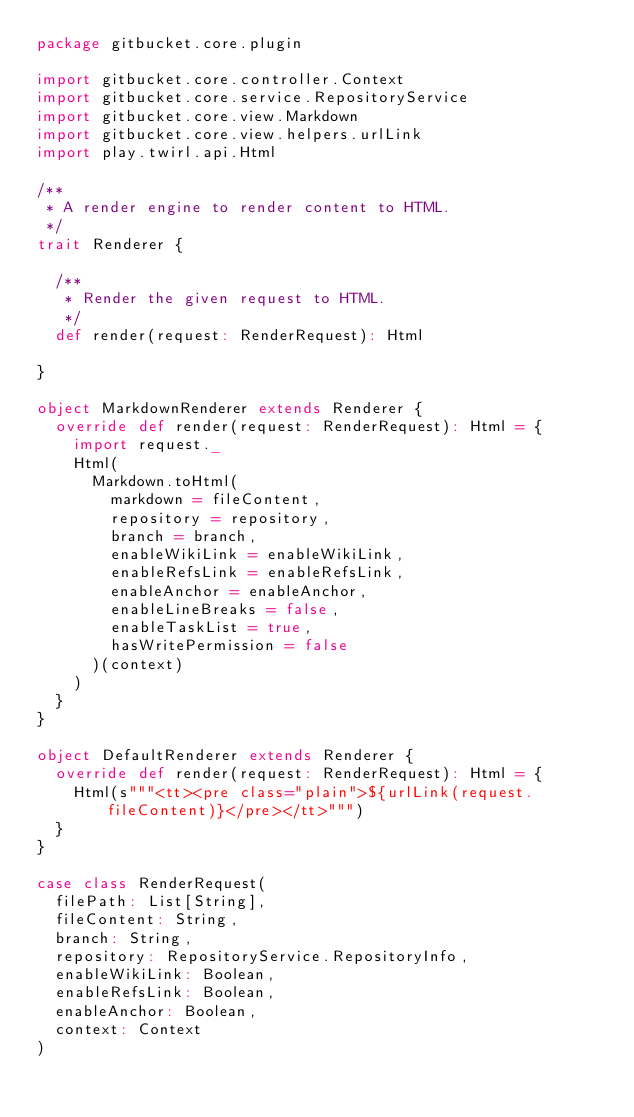<code> <loc_0><loc_0><loc_500><loc_500><_Scala_>package gitbucket.core.plugin

import gitbucket.core.controller.Context
import gitbucket.core.service.RepositoryService
import gitbucket.core.view.Markdown
import gitbucket.core.view.helpers.urlLink
import play.twirl.api.Html

/**
 * A render engine to render content to HTML.
 */
trait Renderer {

  /**
   * Render the given request to HTML.
   */
  def render(request: RenderRequest): Html

}

object MarkdownRenderer extends Renderer {
  override def render(request: RenderRequest): Html = {
    import request._
    Html(
      Markdown.toHtml(
        markdown = fileContent,
        repository = repository,
        branch = branch,
        enableWikiLink = enableWikiLink,
        enableRefsLink = enableRefsLink,
        enableAnchor = enableAnchor,
        enableLineBreaks = false,
        enableTaskList = true,
        hasWritePermission = false
      )(context)
    )
  }
}

object DefaultRenderer extends Renderer {
  override def render(request: RenderRequest): Html = {
    Html(s"""<tt><pre class="plain">${urlLink(request.fileContent)}</pre></tt>""")
  }
}

case class RenderRequest(
  filePath: List[String],
  fileContent: String,
  branch: String,
  repository: RepositoryService.RepositoryInfo,
  enableWikiLink: Boolean,
  enableRefsLink: Boolean,
  enableAnchor: Boolean,
  context: Context
)
</code> 